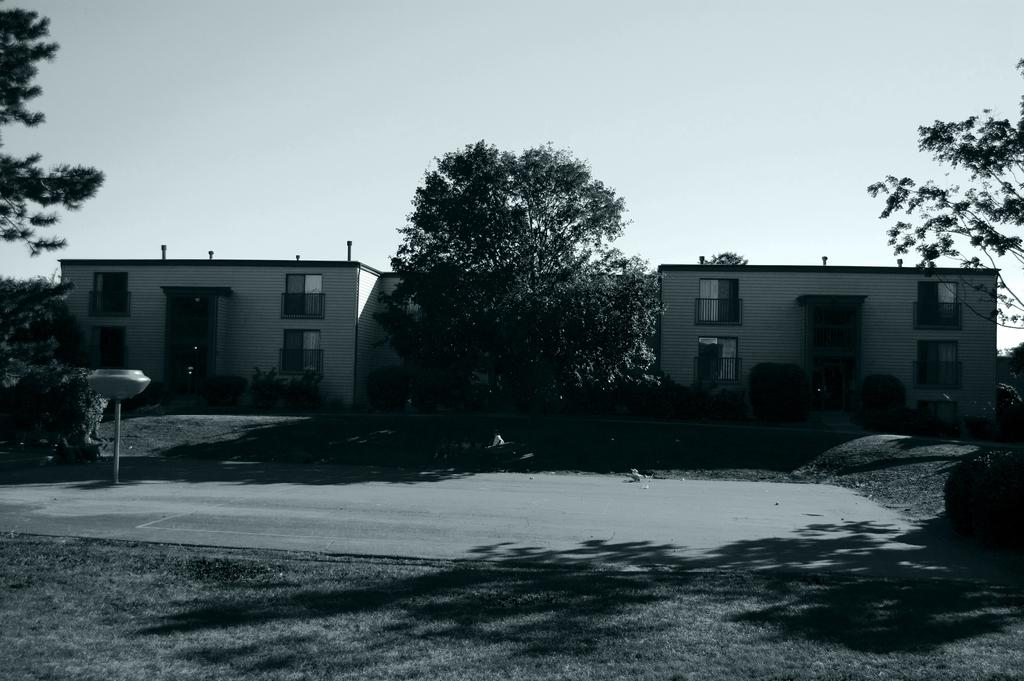What type of structures can be seen in the image? There are buildings in the image. What other natural elements are present in the image? There are trees and plants in the image. What is visible at the top of the image? The sky is visible at the top of the image. What type of flowers can be seen in the bedroom in the image? There is no bedroom or flowers present in the image; it features buildings, trees, plants, and the sky. 